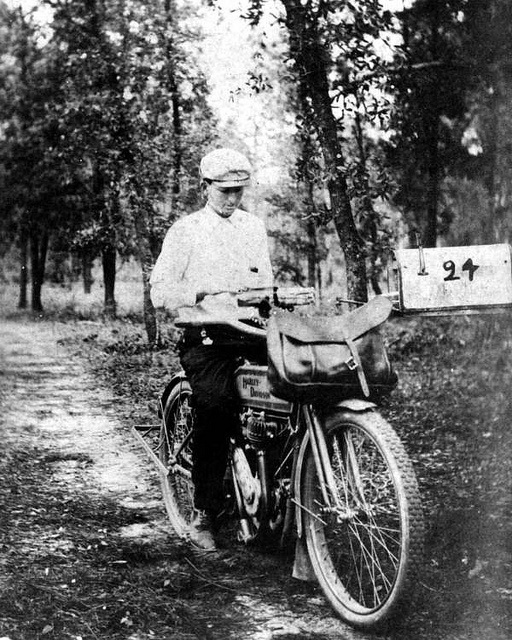Describe the objects in this image and their specific colors. I can see motorcycle in lightgray, black, gray, and darkgray tones, people in lightgray, black, darkgray, and gray tones, and handbag in lightgray, black, darkgray, and gray tones in this image. 